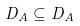Convert formula to latex. <formula><loc_0><loc_0><loc_500><loc_500>D _ { A } \subseteq D _ { A }</formula> 